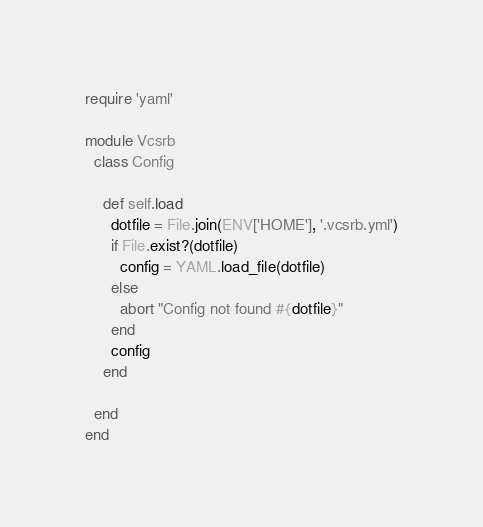<code> <loc_0><loc_0><loc_500><loc_500><_Ruby_>require 'yaml'

module Vcsrb
  class Config

    def self.load
      dotfile = File.join(ENV['HOME'], '.vcsrb.yml')
      if File.exist?(dotfile)
        config = YAML.load_file(dotfile)
      else
        abort "Config not found #{dotfile}"
      end
      config
    end

  end
end
</code> 